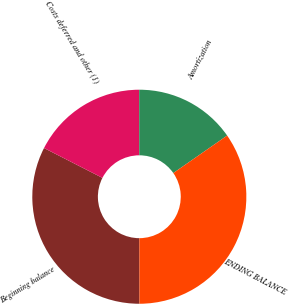Convert chart to OTSL. <chart><loc_0><loc_0><loc_500><loc_500><pie_chart><fcel>Beginning balance<fcel>Costs deferred and other (1)<fcel>Amortization<fcel>ENDING BALANCE<nl><fcel>32.54%<fcel>17.46%<fcel>15.34%<fcel>34.66%<nl></chart> 